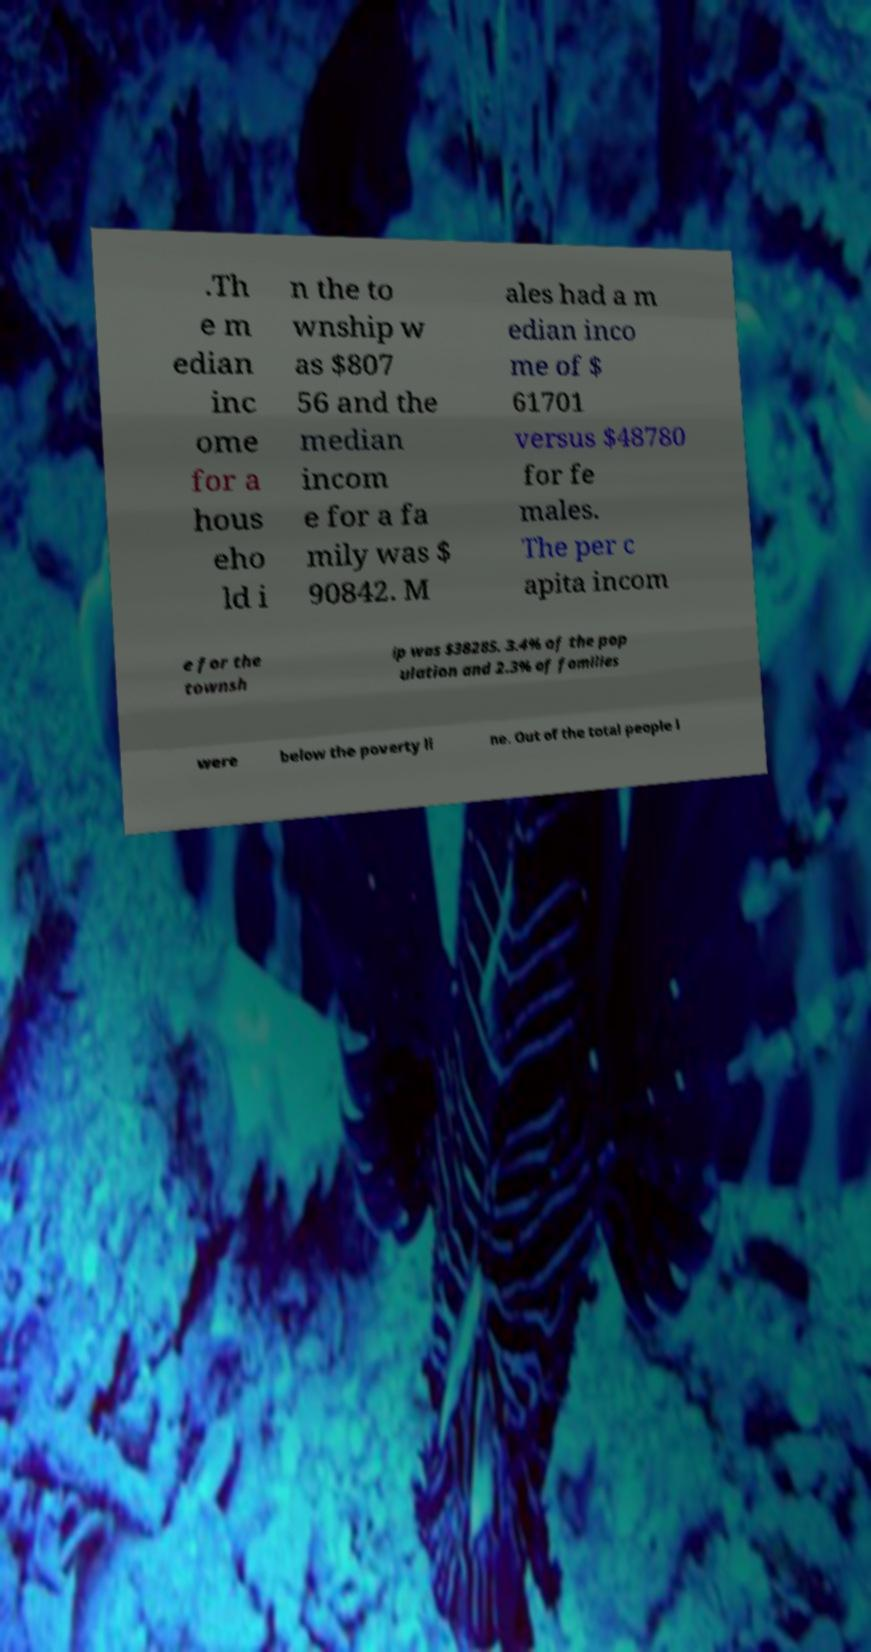Could you assist in decoding the text presented in this image and type it out clearly? .Th e m edian inc ome for a hous eho ld i n the to wnship w as $807 56 and the median incom e for a fa mily was $ 90842. M ales had a m edian inco me of $ 61701 versus $48780 for fe males. The per c apita incom e for the townsh ip was $38285. 3.4% of the pop ulation and 2.3% of families were below the poverty li ne. Out of the total people l 